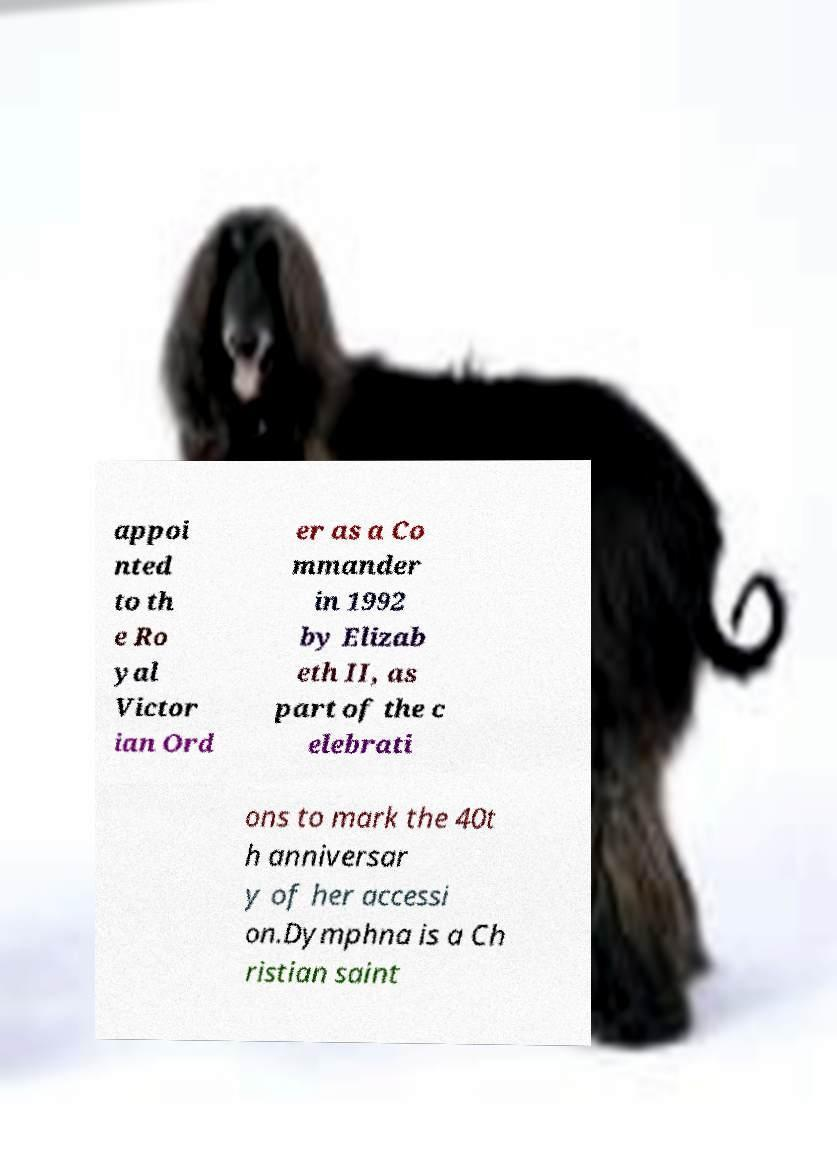Please identify and transcribe the text found in this image. appoi nted to th e Ro yal Victor ian Ord er as a Co mmander in 1992 by Elizab eth II, as part of the c elebrati ons to mark the 40t h anniversar y of her accessi on.Dymphna is a Ch ristian saint 